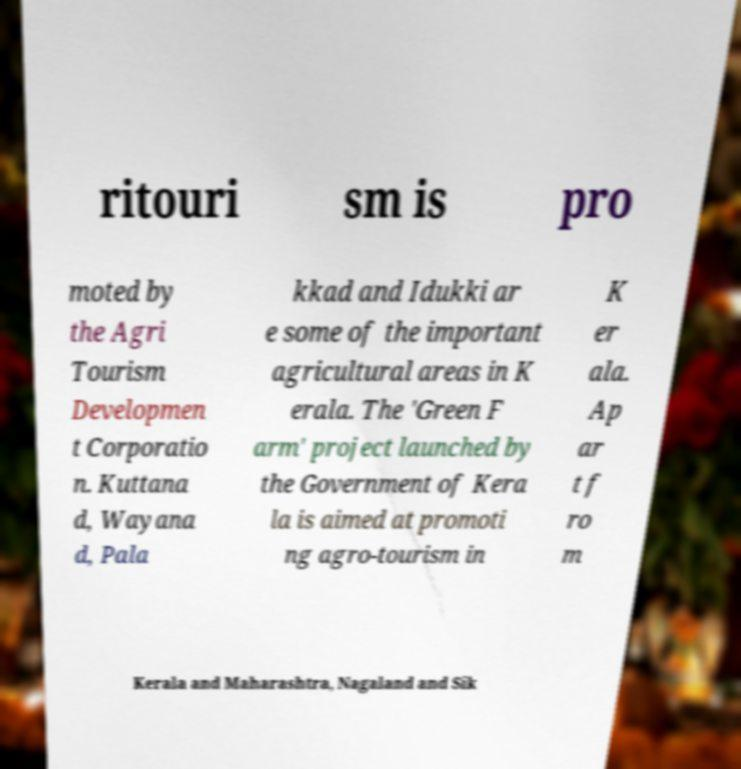Please read and relay the text visible in this image. What does it say? ritouri sm is pro moted by the Agri Tourism Developmen t Corporatio n. Kuttana d, Wayana d, Pala kkad and Idukki ar e some of the important agricultural areas in K erala. The 'Green F arm' project launched by the Government of Kera la is aimed at promoti ng agro-tourism in K er ala. Ap ar t f ro m Kerala and Maharashtra, Nagaland and Sik 